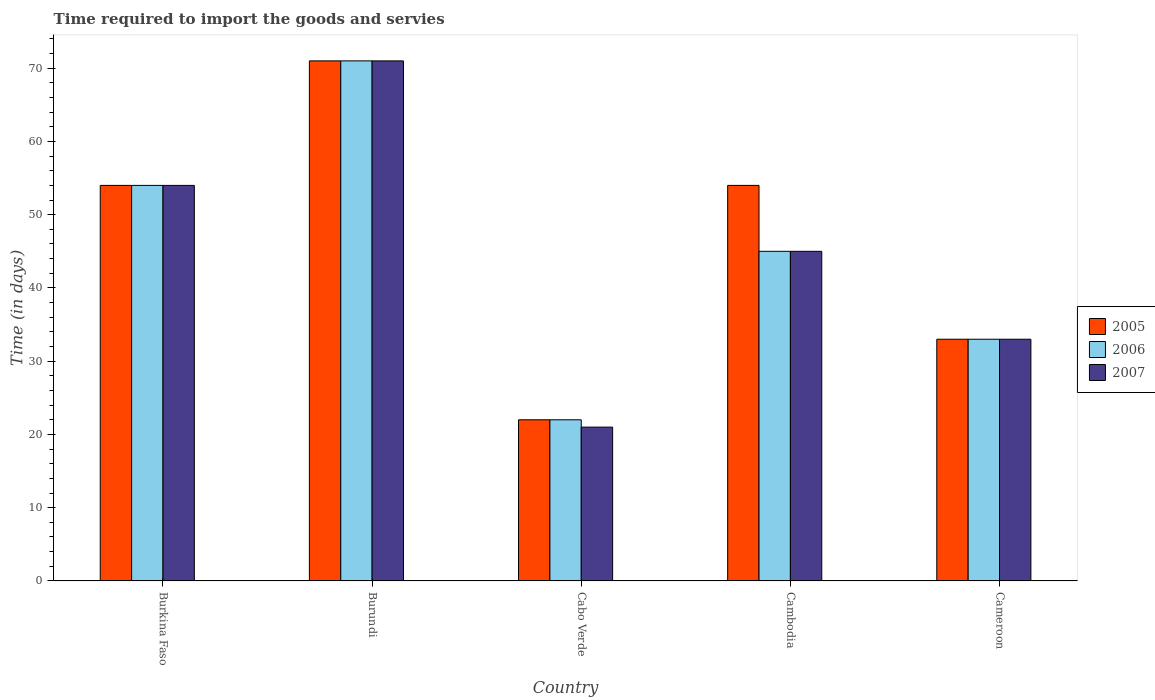How many different coloured bars are there?
Provide a short and direct response. 3. Are the number of bars per tick equal to the number of legend labels?
Ensure brevity in your answer.  Yes. Are the number of bars on each tick of the X-axis equal?
Keep it short and to the point. Yes. How many bars are there on the 2nd tick from the left?
Keep it short and to the point. 3. How many bars are there on the 4th tick from the right?
Make the answer very short. 3. What is the label of the 5th group of bars from the left?
Provide a short and direct response. Cameroon. What is the number of days required to import the goods and services in 2006 in Cameroon?
Provide a succinct answer. 33. Across all countries, what is the maximum number of days required to import the goods and services in 2006?
Ensure brevity in your answer.  71. In which country was the number of days required to import the goods and services in 2007 maximum?
Your answer should be compact. Burundi. In which country was the number of days required to import the goods and services in 2007 minimum?
Ensure brevity in your answer.  Cabo Verde. What is the total number of days required to import the goods and services in 2005 in the graph?
Your answer should be compact. 234. What is the difference between the number of days required to import the goods and services in 2005 in Cameroon and the number of days required to import the goods and services in 2007 in Burkina Faso?
Your answer should be very brief. -21. What is the average number of days required to import the goods and services in 2006 per country?
Ensure brevity in your answer.  45. In how many countries, is the number of days required to import the goods and services in 2007 greater than 56 days?
Keep it short and to the point. 1. What is the ratio of the number of days required to import the goods and services in 2007 in Cabo Verde to that in Cameroon?
Keep it short and to the point. 0.64. Is the number of days required to import the goods and services in 2007 in Burundi less than that in Cabo Verde?
Provide a succinct answer. No. Is the difference between the number of days required to import the goods and services in 2006 in Cambodia and Cameroon greater than the difference between the number of days required to import the goods and services in 2007 in Cambodia and Cameroon?
Keep it short and to the point. No. What is the difference between the highest and the second highest number of days required to import the goods and services in 2007?
Give a very brief answer. -9. What is the difference between the highest and the lowest number of days required to import the goods and services in 2006?
Provide a succinct answer. 49. Is the sum of the number of days required to import the goods and services in 2005 in Cabo Verde and Cameroon greater than the maximum number of days required to import the goods and services in 2006 across all countries?
Ensure brevity in your answer.  No. What does the 1st bar from the left in Cameroon represents?
Your response must be concise. 2005. What does the 1st bar from the right in Cambodia represents?
Offer a very short reply. 2007. Is it the case that in every country, the sum of the number of days required to import the goods and services in 2006 and number of days required to import the goods and services in 2007 is greater than the number of days required to import the goods and services in 2005?
Provide a short and direct response. Yes. Are the values on the major ticks of Y-axis written in scientific E-notation?
Ensure brevity in your answer.  No. Does the graph contain any zero values?
Your answer should be compact. No. Does the graph contain grids?
Give a very brief answer. No. What is the title of the graph?
Provide a short and direct response. Time required to import the goods and servies. What is the label or title of the X-axis?
Provide a short and direct response. Country. What is the label or title of the Y-axis?
Keep it short and to the point. Time (in days). What is the Time (in days) of 2007 in Burkina Faso?
Your response must be concise. 54. What is the Time (in days) of 2005 in Burundi?
Make the answer very short. 71. What is the Time (in days) in 2006 in Burundi?
Provide a succinct answer. 71. What is the Time (in days) in 2007 in Burundi?
Your response must be concise. 71. What is the Time (in days) of 2006 in Cabo Verde?
Make the answer very short. 22. What is the Time (in days) of 2005 in Cambodia?
Offer a very short reply. 54. What is the Time (in days) of 2006 in Cambodia?
Give a very brief answer. 45. What is the Time (in days) of 2007 in Cambodia?
Make the answer very short. 45. What is the Time (in days) of 2006 in Cameroon?
Offer a very short reply. 33. What is the Time (in days) of 2007 in Cameroon?
Give a very brief answer. 33. Across all countries, what is the maximum Time (in days) of 2006?
Offer a terse response. 71. Across all countries, what is the maximum Time (in days) of 2007?
Offer a very short reply. 71. Across all countries, what is the minimum Time (in days) of 2005?
Your answer should be compact. 22. What is the total Time (in days) in 2005 in the graph?
Give a very brief answer. 234. What is the total Time (in days) in 2006 in the graph?
Your answer should be very brief. 225. What is the total Time (in days) in 2007 in the graph?
Offer a very short reply. 224. What is the difference between the Time (in days) of 2007 in Burkina Faso and that in Burundi?
Your response must be concise. -17. What is the difference between the Time (in days) in 2006 in Burkina Faso and that in Cabo Verde?
Your answer should be very brief. 32. What is the difference between the Time (in days) of 2007 in Burkina Faso and that in Cabo Verde?
Your answer should be compact. 33. What is the difference between the Time (in days) of 2005 in Burkina Faso and that in Cambodia?
Give a very brief answer. 0. What is the difference between the Time (in days) of 2006 in Burkina Faso and that in Cameroon?
Provide a succinct answer. 21. What is the difference between the Time (in days) in 2005 in Burundi and that in Cabo Verde?
Make the answer very short. 49. What is the difference between the Time (in days) of 2006 in Burundi and that in Cabo Verde?
Keep it short and to the point. 49. What is the difference between the Time (in days) in 2007 in Burundi and that in Cabo Verde?
Your answer should be very brief. 50. What is the difference between the Time (in days) in 2005 in Cabo Verde and that in Cambodia?
Provide a succinct answer. -32. What is the difference between the Time (in days) of 2007 in Cabo Verde and that in Cambodia?
Make the answer very short. -24. What is the difference between the Time (in days) in 2005 in Cabo Verde and that in Cameroon?
Keep it short and to the point. -11. What is the difference between the Time (in days) of 2006 in Cabo Verde and that in Cameroon?
Give a very brief answer. -11. What is the difference between the Time (in days) of 2005 in Cambodia and that in Cameroon?
Provide a short and direct response. 21. What is the difference between the Time (in days) of 2005 in Burkina Faso and the Time (in days) of 2007 in Burundi?
Your response must be concise. -17. What is the difference between the Time (in days) in 2006 in Burkina Faso and the Time (in days) in 2007 in Burundi?
Keep it short and to the point. -17. What is the difference between the Time (in days) in 2005 in Burkina Faso and the Time (in days) in 2007 in Cabo Verde?
Offer a terse response. 33. What is the difference between the Time (in days) in 2006 in Burkina Faso and the Time (in days) in 2007 in Cabo Verde?
Offer a very short reply. 33. What is the difference between the Time (in days) of 2005 in Burkina Faso and the Time (in days) of 2007 in Cambodia?
Your answer should be very brief. 9. What is the difference between the Time (in days) of 2006 in Burkina Faso and the Time (in days) of 2007 in Cambodia?
Make the answer very short. 9. What is the difference between the Time (in days) of 2005 in Burkina Faso and the Time (in days) of 2006 in Cameroon?
Your answer should be very brief. 21. What is the difference between the Time (in days) in 2006 in Burkina Faso and the Time (in days) in 2007 in Cameroon?
Provide a succinct answer. 21. What is the difference between the Time (in days) of 2005 in Burundi and the Time (in days) of 2006 in Cambodia?
Your answer should be very brief. 26. What is the difference between the Time (in days) in 2005 in Burundi and the Time (in days) in 2007 in Cambodia?
Offer a very short reply. 26. What is the difference between the Time (in days) in 2005 in Burundi and the Time (in days) in 2006 in Cameroon?
Your answer should be very brief. 38. What is the difference between the Time (in days) of 2005 in Burundi and the Time (in days) of 2007 in Cameroon?
Offer a terse response. 38. What is the difference between the Time (in days) in 2006 in Burundi and the Time (in days) in 2007 in Cameroon?
Provide a succinct answer. 38. What is the difference between the Time (in days) of 2005 in Cambodia and the Time (in days) of 2006 in Cameroon?
Your answer should be compact. 21. What is the difference between the Time (in days) in 2005 in Cambodia and the Time (in days) in 2007 in Cameroon?
Keep it short and to the point. 21. What is the difference between the Time (in days) in 2006 in Cambodia and the Time (in days) in 2007 in Cameroon?
Your response must be concise. 12. What is the average Time (in days) in 2005 per country?
Provide a short and direct response. 46.8. What is the average Time (in days) in 2007 per country?
Give a very brief answer. 44.8. What is the difference between the Time (in days) in 2005 and Time (in days) in 2006 in Burkina Faso?
Your response must be concise. 0. What is the difference between the Time (in days) of 2005 and Time (in days) of 2006 in Burundi?
Provide a short and direct response. 0. What is the difference between the Time (in days) of 2005 and Time (in days) of 2007 in Burundi?
Give a very brief answer. 0. What is the difference between the Time (in days) of 2006 and Time (in days) of 2007 in Cabo Verde?
Your response must be concise. 1. What is the difference between the Time (in days) in 2005 and Time (in days) in 2006 in Cambodia?
Make the answer very short. 9. What is the difference between the Time (in days) in 2006 and Time (in days) in 2007 in Cambodia?
Provide a short and direct response. 0. What is the difference between the Time (in days) in 2005 and Time (in days) in 2007 in Cameroon?
Your response must be concise. 0. What is the ratio of the Time (in days) of 2005 in Burkina Faso to that in Burundi?
Your response must be concise. 0.76. What is the ratio of the Time (in days) of 2006 in Burkina Faso to that in Burundi?
Offer a terse response. 0.76. What is the ratio of the Time (in days) of 2007 in Burkina Faso to that in Burundi?
Your answer should be very brief. 0.76. What is the ratio of the Time (in days) in 2005 in Burkina Faso to that in Cabo Verde?
Provide a succinct answer. 2.45. What is the ratio of the Time (in days) in 2006 in Burkina Faso to that in Cabo Verde?
Offer a terse response. 2.45. What is the ratio of the Time (in days) of 2007 in Burkina Faso to that in Cabo Verde?
Give a very brief answer. 2.57. What is the ratio of the Time (in days) of 2005 in Burkina Faso to that in Cambodia?
Offer a terse response. 1. What is the ratio of the Time (in days) in 2006 in Burkina Faso to that in Cambodia?
Provide a short and direct response. 1.2. What is the ratio of the Time (in days) in 2007 in Burkina Faso to that in Cambodia?
Give a very brief answer. 1.2. What is the ratio of the Time (in days) in 2005 in Burkina Faso to that in Cameroon?
Offer a very short reply. 1.64. What is the ratio of the Time (in days) in 2006 in Burkina Faso to that in Cameroon?
Offer a terse response. 1.64. What is the ratio of the Time (in days) of 2007 in Burkina Faso to that in Cameroon?
Provide a succinct answer. 1.64. What is the ratio of the Time (in days) in 2005 in Burundi to that in Cabo Verde?
Ensure brevity in your answer.  3.23. What is the ratio of the Time (in days) of 2006 in Burundi to that in Cabo Verde?
Make the answer very short. 3.23. What is the ratio of the Time (in days) of 2007 in Burundi to that in Cabo Verde?
Your response must be concise. 3.38. What is the ratio of the Time (in days) of 2005 in Burundi to that in Cambodia?
Give a very brief answer. 1.31. What is the ratio of the Time (in days) in 2006 in Burundi to that in Cambodia?
Offer a very short reply. 1.58. What is the ratio of the Time (in days) in 2007 in Burundi to that in Cambodia?
Ensure brevity in your answer.  1.58. What is the ratio of the Time (in days) in 2005 in Burundi to that in Cameroon?
Offer a terse response. 2.15. What is the ratio of the Time (in days) in 2006 in Burundi to that in Cameroon?
Offer a very short reply. 2.15. What is the ratio of the Time (in days) in 2007 in Burundi to that in Cameroon?
Your response must be concise. 2.15. What is the ratio of the Time (in days) in 2005 in Cabo Verde to that in Cambodia?
Ensure brevity in your answer.  0.41. What is the ratio of the Time (in days) of 2006 in Cabo Verde to that in Cambodia?
Your answer should be compact. 0.49. What is the ratio of the Time (in days) of 2007 in Cabo Verde to that in Cambodia?
Make the answer very short. 0.47. What is the ratio of the Time (in days) of 2007 in Cabo Verde to that in Cameroon?
Offer a terse response. 0.64. What is the ratio of the Time (in days) of 2005 in Cambodia to that in Cameroon?
Offer a terse response. 1.64. What is the ratio of the Time (in days) of 2006 in Cambodia to that in Cameroon?
Your answer should be very brief. 1.36. What is the ratio of the Time (in days) in 2007 in Cambodia to that in Cameroon?
Provide a succinct answer. 1.36. What is the difference between the highest and the second highest Time (in days) of 2005?
Make the answer very short. 17. What is the difference between the highest and the lowest Time (in days) of 2006?
Ensure brevity in your answer.  49. 